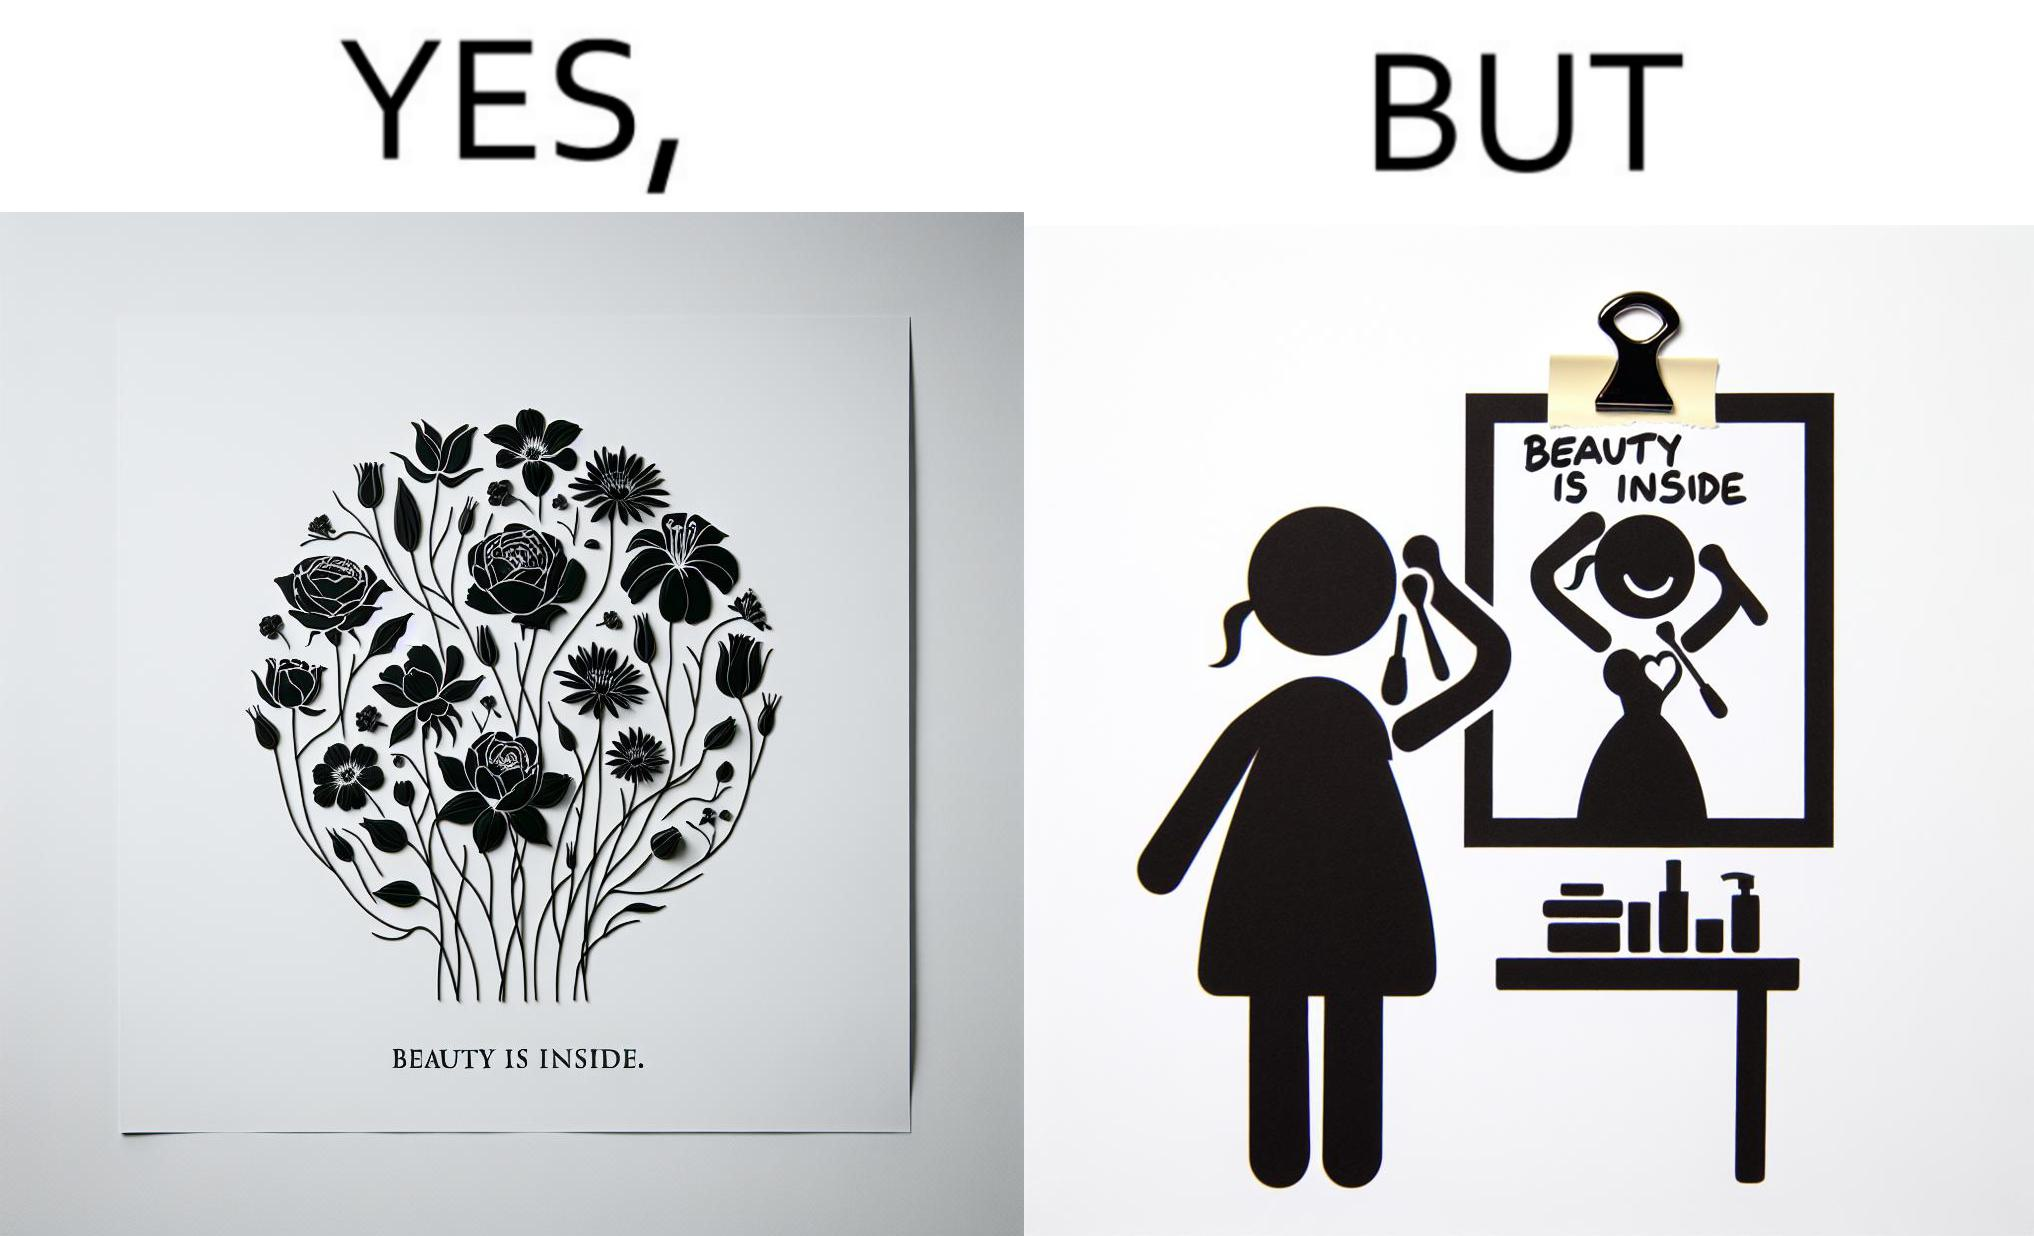What do you see in each half of this image? In the left part of the image: The image shows a text in beautiful font with flowers drawn around it. The text says "Beauty Is Inside". In the right part of the image: The image shows a woman applying makeup after shower by looking at herself in the dressing mirror. A piece of paper that says "Beauty is Inside" is clipped to the top of the mirror. 